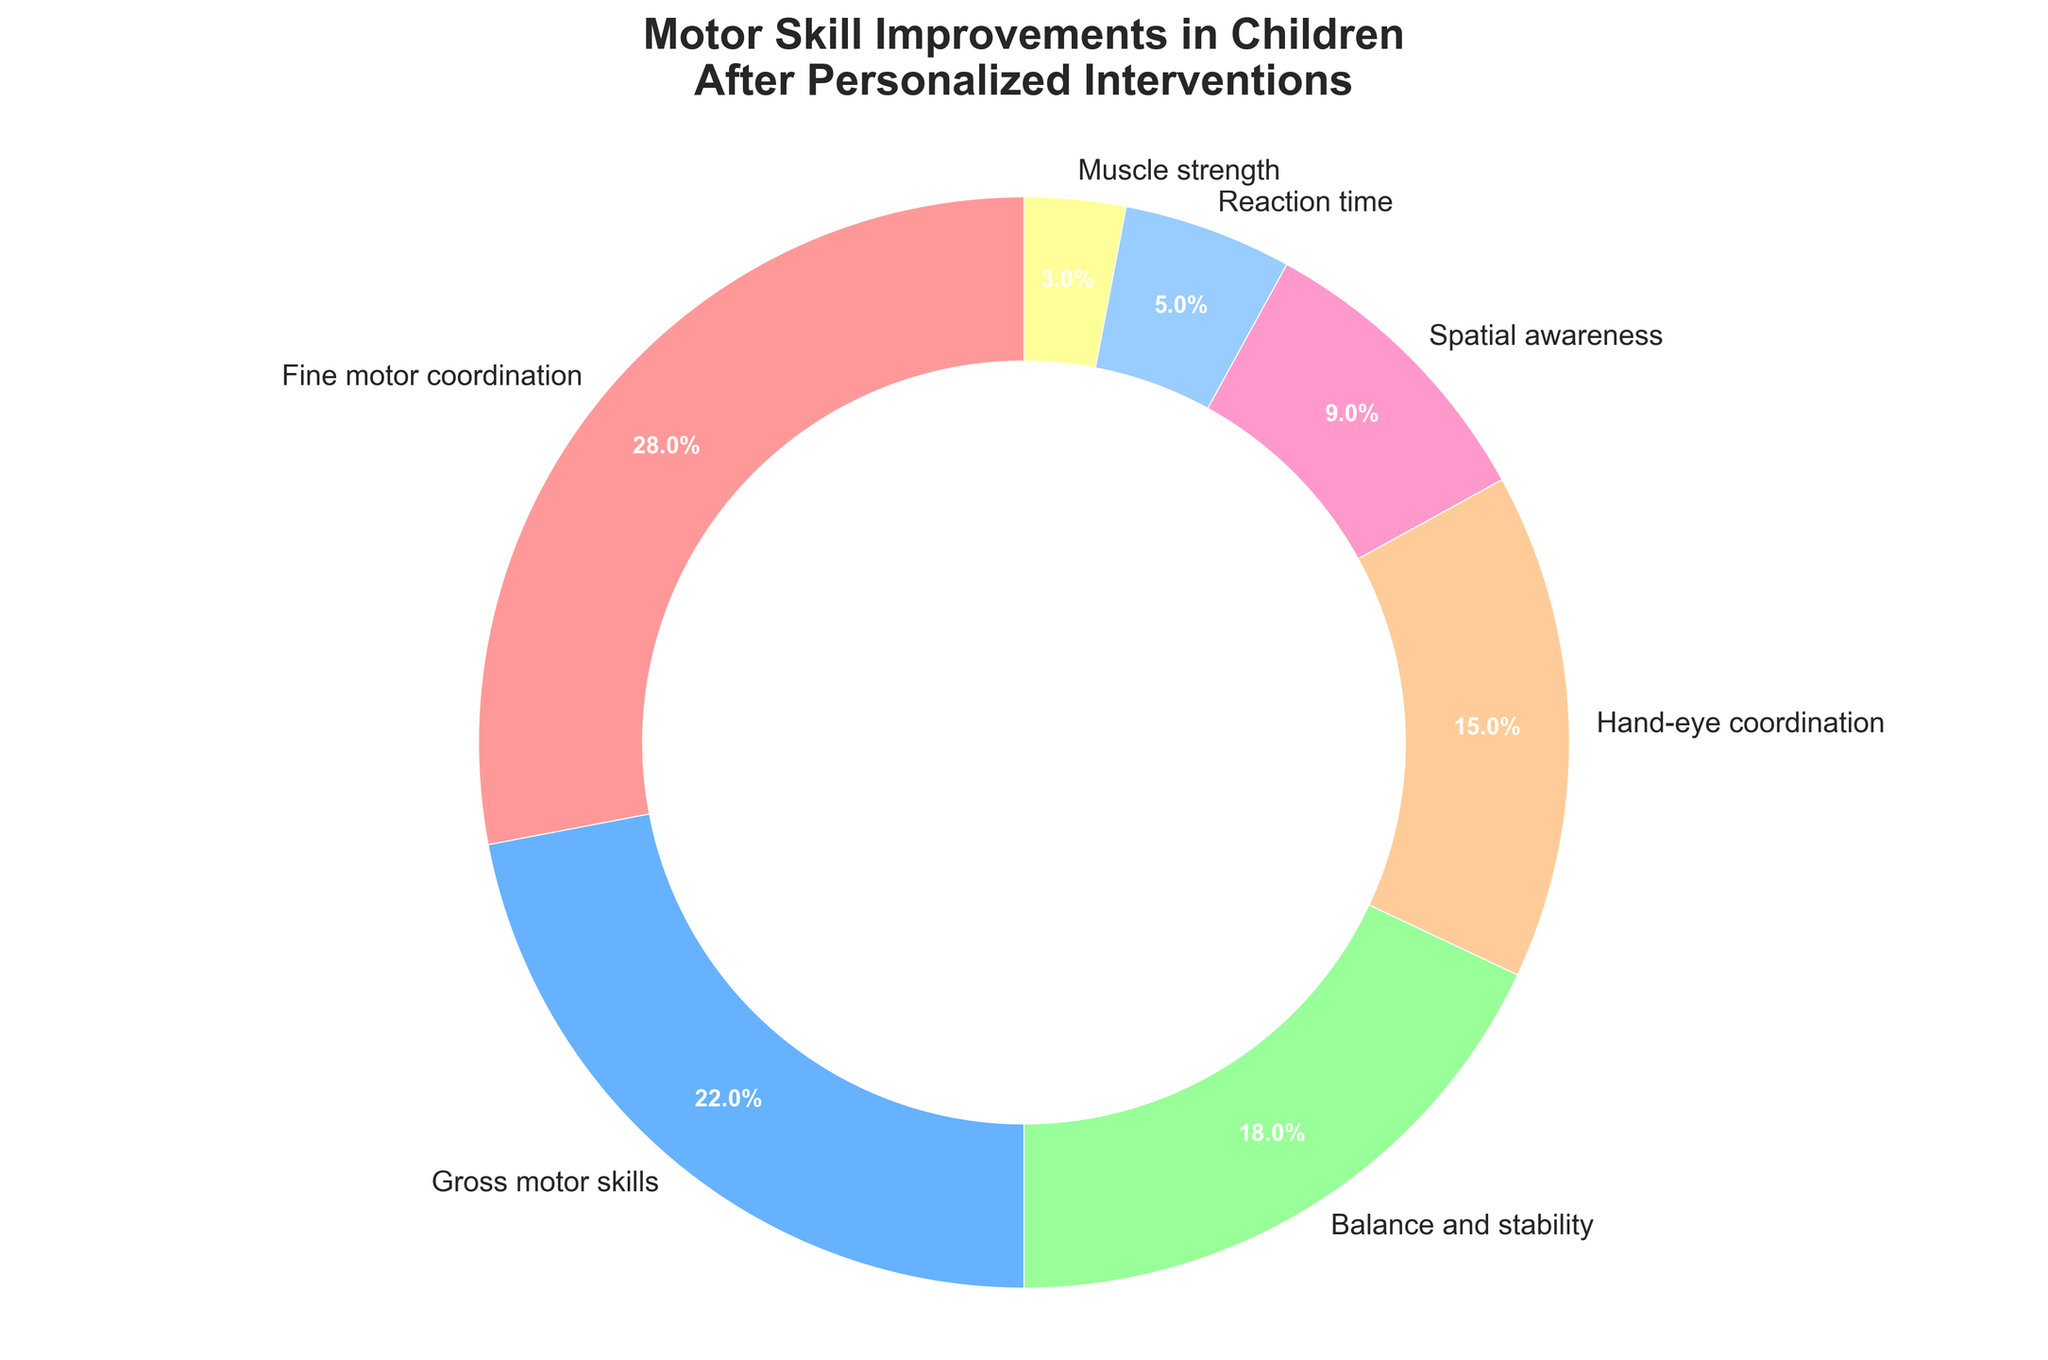What's the largest observed motor skill improvement in children after personalized interventions? The figure shows various motor skill improvements with associated percentages. We can see "Fine motor coordination" has the highest percentage.
Answer: Fine motor coordination What's the difference in percentages between "Gross motor skills" and "Reaction time"? "Gross motor skills" has a percentage of 22%, and "Reaction time" has 5%. Subtract 5 from 22 to find the difference.
Answer: 17% What's the combined percentage of "Balance and stability" and "Hand-eye coordination"? "Balance and stability" has a percentage of 18%, and "Hand-eye coordination" has 15%. Add these two values together to find the total percentage.
Answer: 33% Which motor skill improvement is represented by the yellow section of the pie chart? In the pie chart, we can see that the yellow section corresponds to "Spatial awareness."
Answer: Spatial awareness How many motor skill improvements have a percentage greater than 10%? By examining the percentages in the chart, the motor skill improvements greater than 10% are "Fine motor coordination" (28%), "Gross motor skills" (22%), "Balance and stability" (18%), and "Hand-eye coordination" (15%). Count these to find the total number.
Answer: Four What's the sum of the percentages for the three smallest motor skill improvements? The three smallest percentages are "Muscle strength" (3%), "Reaction time" (5%), and "Spatial awareness" (9%). Add these values together to find the sum.
Answer: 17% Is "Hand-eye coordination" improvement percentage greater than "Balance and stability"? "Hand-eye coordination" has a percentage of 15%, and "Balance and stability" has 18%. Compare these to determine which is greater.
Answer: No Which motor skill improvement has the smallest percentage? By examining the pie chart, "Muscle strength" has the smallest percentage at 3%.
Answer: Muscle strength What's the difference between the largest and the smallest observed motor skill improvements? The largest percentage is for "Fine motor coordination" (28%) and the smallest is "Muscle strength" (3%). Subtract 3 from 28 to find the difference.
Answer: 25% Which motor skill improvement is just under the halfway mark in terms of percentage share? By examining the percentages, "Balance and stability" has 18% and "Hand-eye coordination" has 15%, the latter being just under the next highest percentage.
Answer: Hand-eye coordination 